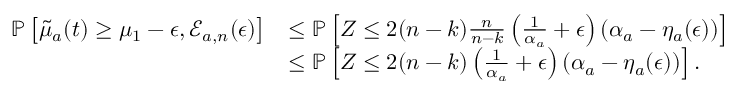Convert formula to latex. <formula><loc_0><loc_0><loc_500><loc_500>\begin{array} { r l } { \mathbb { P } \left [ \tilde { \mu } _ { a } ( t ) \geq \mu _ { 1 } - \epsilon , \mathcal { E } _ { a , n } ( \epsilon ) \right ] } & { \leq \mathbb { P } \left [ Z \leq 2 ( n - k ) \frac { n } { n - k } \left ( \frac { 1 } { \alpha _ { a } } + \epsilon \right ) \left ( \alpha _ { a } - \eta _ { a } ( \epsilon ) \right ) \right ] } \\ & { \leq \mathbb { P } \left [ Z \leq 2 ( n - k ) \left ( \frac { 1 } { \alpha _ { a } } + \epsilon \right ) \left ( \alpha _ { a } - \eta _ { a } ( \epsilon ) \right ) \right ] . } \end{array}</formula> 